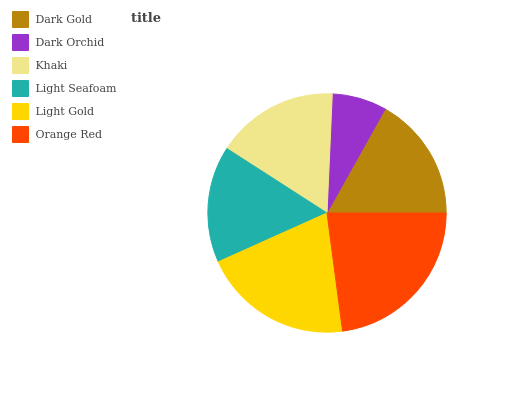Is Dark Orchid the minimum?
Answer yes or no. Yes. Is Orange Red the maximum?
Answer yes or no. Yes. Is Khaki the minimum?
Answer yes or no. No. Is Khaki the maximum?
Answer yes or no. No. Is Khaki greater than Dark Orchid?
Answer yes or no. Yes. Is Dark Orchid less than Khaki?
Answer yes or no. Yes. Is Dark Orchid greater than Khaki?
Answer yes or no. No. Is Khaki less than Dark Orchid?
Answer yes or no. No. Is Dark Gold the high median?
Answer yes or no. Yes. Is Khaki the low median?
Answer yes or no. Yes. Is Light Gold the high median?
Answer yes or no. No. Is Light Gold the low median?
Answer yes or no. No. 